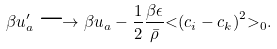Convert formula to latex. <formula><loc_0><loc_0><loc_500><loc_500>\beta u ^ { \prime } _ { a } \longrightarrow \beta u _ { a } - { \frac { 1 } { 2 } } \frac { \beta \epsilon } { \bar { \rho } } \mathopen < \left ( c _ { i } - c _ { k } \right ) ^ { 2 } \mathclose > _ { 0 } .</formula> 